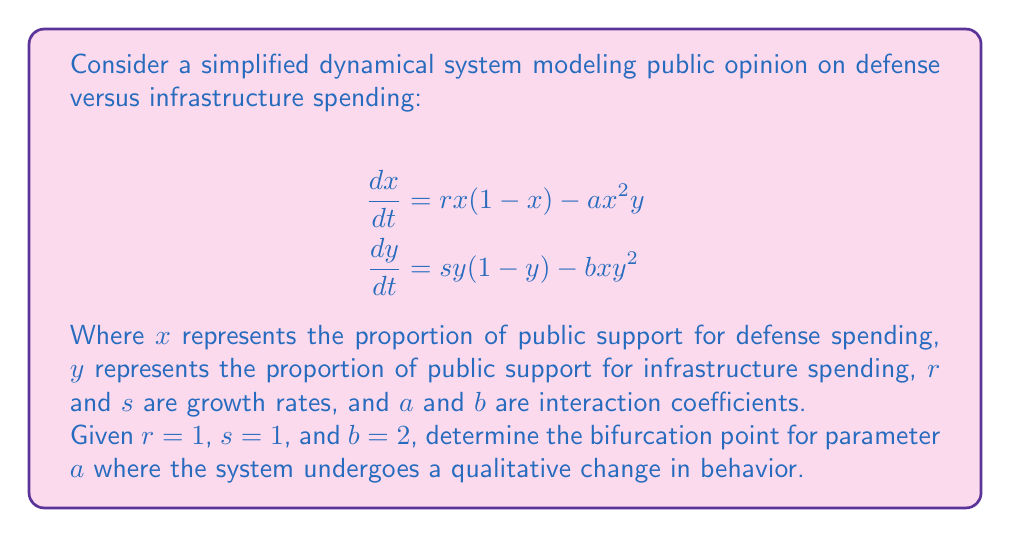Provide a solution to this math problem. To find the bifurcation point, we need to follow these steps:

1) First, find the equilibrium points by setting both equations to zero:

   $$rx(1-x) - ax^2y = 0$$
   $$sy(1-y) - bxy^2 = 0$$

2) Solve for the non-trivial equilibrium point (excluding (0,0) and (1,1)):

   $$x = 1 - \frac{ax^2y}{r} = 1 - ax^2y$$
   $$y = 1 - \frac{bxy^2}{s} = 1 - 2xy^2$$

3) Substitute the expression for $y$ into the equation for $x$:

   $$x = 1 - ax^2(1 - 2xy^2)$$

4) Expand and simplify:

   $$x = 1 - ax^2 + 2ax^3y^2$$
   $$x = 1 - ax^2 + 2ax^3(1 - 2xy^2)$$
   $$x = 1 - ax^2 + 2ax^3 - 4ax^4y^2$$

5) The bifurcation occurs when this equation has a double root, which happens when its discriminant is zero. The discriminant of a cubic equation $Ax^3 + Bx^2 + Cx + D = 0$ is given by:

   $$\Delta = 18ABCD - 4B^3D + B^2C^2 - 4AC^3 - 27A^2D^2$$

6) In our case, $A = 2a$, $B = -a$, $C = -1$, and $D = 1$. Substituting these into the discriminant formula:

   $$\Delta = 18(2a)(-a)(-1)(1) - 4(-a)^3(1) + (-a)^2(-1)^2 - 4(2a)(-1)^3 - 27(2a)^2(1)^2$$
   $$\Delta = 36a^2 - 4a^3 + a^2 - 8a - 108a^2$$
   $$\Delta = -4a^3 - 71a^2 - 8a$$

7) Set this equal to zero to find the bifurcation point:

   $$-4a^3 - 71a^2 - 8a = 0$$
   $$a(-4a^2 - 71a - 8) = 0$$

8) Solve this equation. The non-zero solution is the bifurcation point.

   Using the quadratic formula, we get:
   $$a = \frac{-71 \pm \sqrt{71^2 - 4(-4)(-8)}}{2(-4)} = \frac{-71 \pm \sqrt{5041 - 128}}{-8} = \frac{-71 \pm \sqrt{4913}}{-8}$$

   $$a \approx 0.1573$$ (rounded to 4 decimal places)
Answer: $a \approx 0.1573$ 